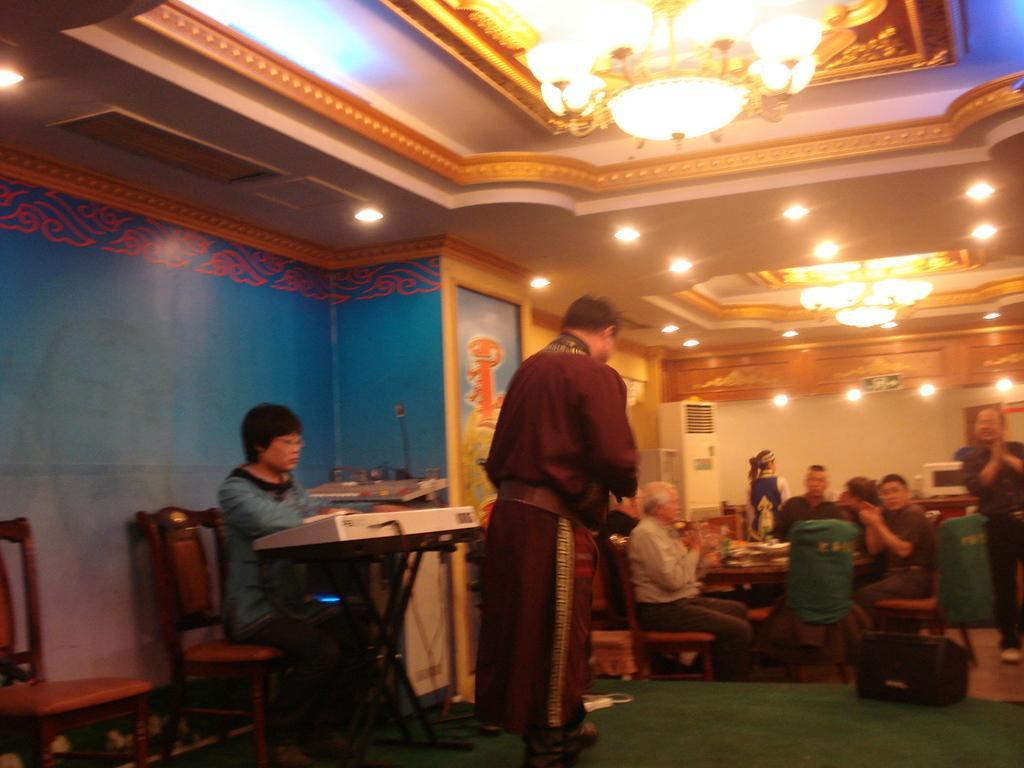Please provide a concise description of this image. As we can see in the image there is a wall, few people sitting on chairs and there is a table. 